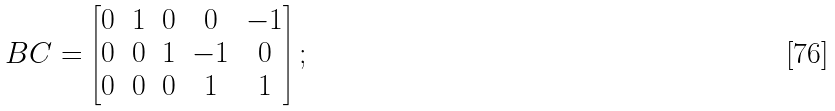Convert formula to latex. <formula><loc_0><loc_0><loc_500><loc_500>\ B C = \begin{bmatrix} 0 & 1 & 0 & 0 & - 1 \\ 0 & 0 & 1 & - 1 & 0 \\ 0 & 0 & 0 & 1 & 1 \end{bmatrix} ;</formula> 